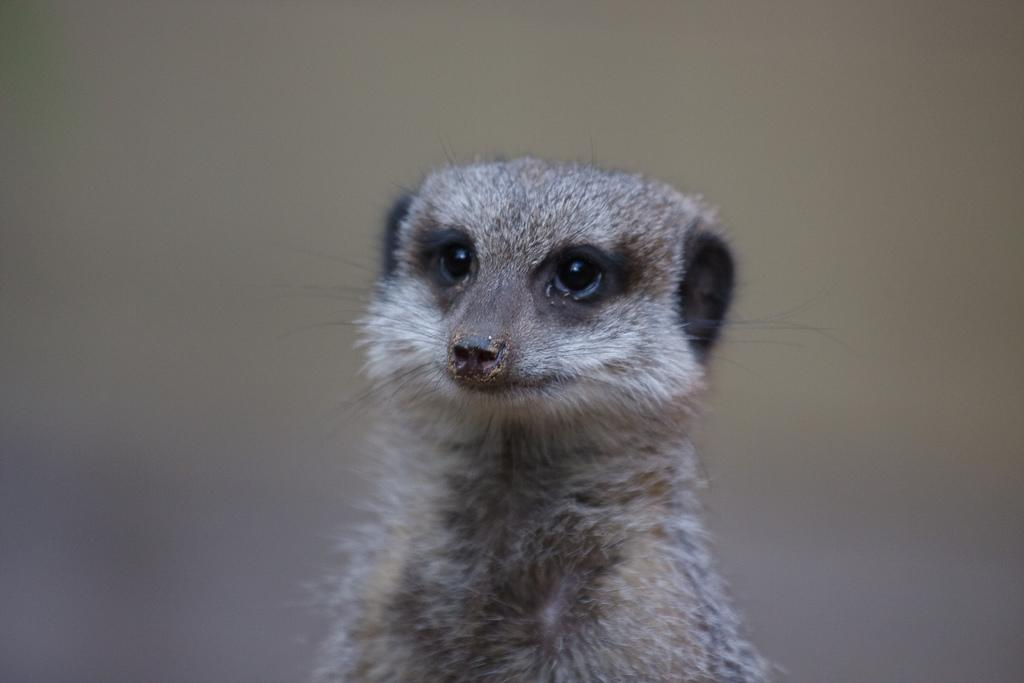What type of animal is in the image? There is a meerkat in the image. What type of volleyball is the meerkat holding in the image? There is no volleyball present in the image; it features a meerkat only. How is the meerkat contributing to education in the image? The image does not depict the meerkat contributing to education, as it only shows the meerkat itself. 